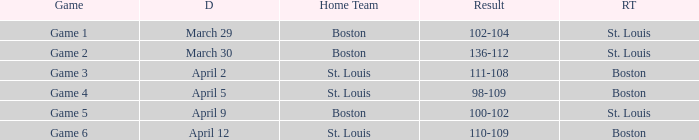Parse the full table. {'header': ['Game', 'D', 'Home Team', 'Result', 'RT'], 'rows': [['Game 1', 'March 29', 'Boston', '102-104', 'St. Louis'], ['Game 2', 'March 30', 'Boston', '136-112', 'St. Louis'], ['Game 3', 'April 2', 'St. Louis', '111-108', 'Boston'], ['Game 4', 'April 5', 'St. Louis', '98-109', 'Boston'], ['Game 5', 'April 9', 'Boston', '100-102', 'St. Louis'], ['Game 6', 'April 12', 'St. Louis', '110-109', 'Boston']]} What Game had a Result of 136-112? Game 2. 